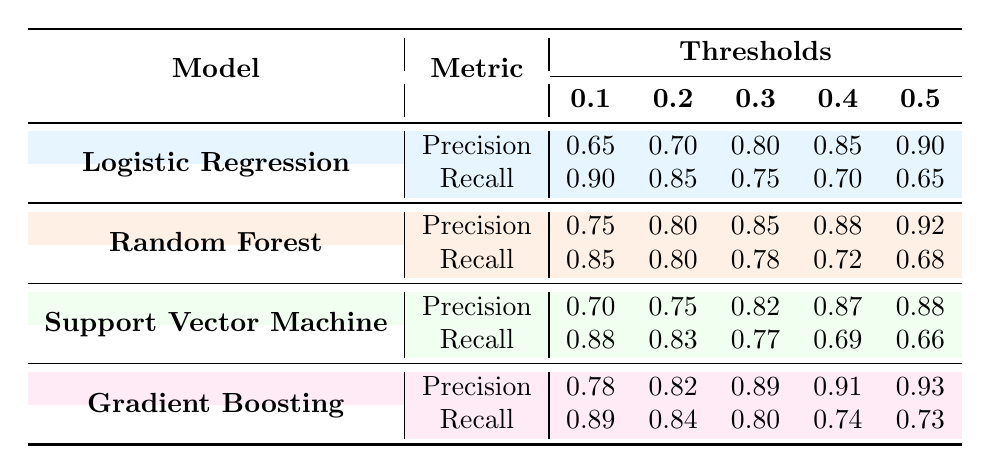What is the precision of the Gradient Boosting model at a threshold of 0.4? From the table, under the column for thresholds, we find the row for Gradient Boosting and look for the value associated with the threshold of 0.4. The precision is listed there as 0.91.
Answer: 0.91 What is the recall rate of the Support Vector Machine model at the highest threshold? We check the Support Vector Machine row and find the recall corresponding to the threshold of 0.5. The value in that cell is 0.66.
Answer: 0.66 Which model shows the highest precision at a threshold of 0.3? Looking at the precision values for all models at the threshold of 0.3, we see that Gradient Boosting has the highest precision value of 0.89.
Answer: Gradient Boosting Is the recall rate of Random Forest at a threshold of 0.1 greater than 0.80? The recall rate for Random Forest at the threshold of 0.1 is 0.85 as per the table. Since 0.85 is indeed greater than 0.80, the answer to the question is yes.
Answer: Yes What is the average precision for Logistic Regression across all thresholds? To find the average precision for Logistic Regression, we sum the precision values (0.65 + 0.70 + 0.80 + 0.85 + 0.90 = 3.90) and then divide by the number of thresholds (5). Thus, the average is 3.90 / 5 = 0.78.
Answer: 0.78 Which model has the largest drop in recall from threshold 0.1 to 0.5? We calculate the differences in recall from threshold 0.1 to 0.5 for each model: Logistic Regression (0.90 - 0.65 = 0.25), Random Forest (0.85 - 0.68 = 0.17), Support Vector Machine (0.88 - 0.66 = 0.22), and Gradient Boosting (0.89 - 0.73 = 0.16). The largest drop is for Logistic Regression at 0.25.
Answer: Logistic Regression Is the precision for Random Forest at a threshold of 0.4 less than that of the Support Vector Machine at the same threshold? From the table, Random Forest's precision at threshold 0.4 is 0.88, while Support Vector Machine's precision at the same threshold is 0.87. Since 0.88 is not less than 0.87, the answer is no.
Answer: No What is the difference in recall between Logistic Regression and Gradient Boosting at the 0.2 threshold? At the 0.2 threshold, Logistic Regression has a recall of 0.85 and Gradient Boosting has a recall of 0.84. The difference is 0.85 - 0.84 = 0.01.
Answer: 0.01 What can be inferred about the overall trend of precision for the models as thresholds increase? Observing the precision values, each model shows a trend of increasing precision with thresholds rising. For example, Logistics Regression goes from 0.65 to 0.90. This indicates models improve precision as the threshold increases.
Answer: Precision increases with thresholds 